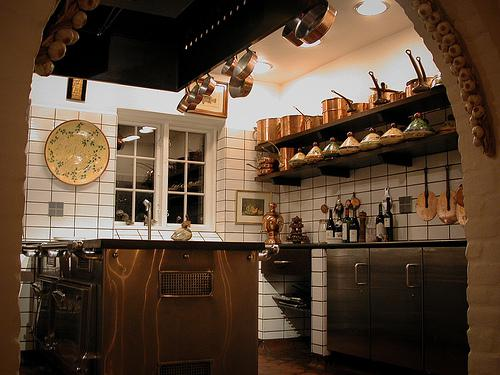Question: how many plates?
Choices:
A. 2.
B. 4.
C. 6.
D. 1.
Answer with the letter. Answer: D Question: when was the picture taken?
Choices:
A. Morning.
B. 2:45.
C. Sunset.
D. Night time.
Answer with the letter. Answer: D Question: what color are the pots?
Choices:
A. Copper.
B. Silver.
C. Black.
D. Pink.
Answer with the letter. Answer: A Question: who is cooking?
Choices:
A. Chef.
B. Mom.
C. Young man.
D. Nobody.
Answer with the letter. Answer: D Question: what color are the cabinets?
Choices:
A. Silver.
B. White.
C. Brown.
D. Black.
Answer with the letter. Answer: A 